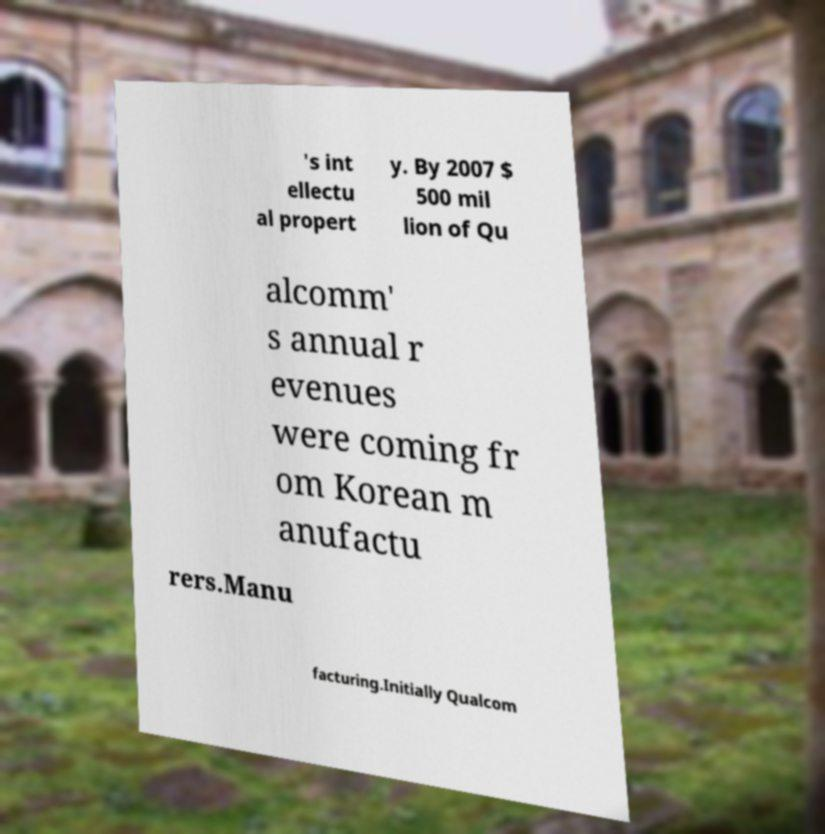There's text embedded in this image that I need extracted. Can you transcribe it verbatim? 's int ellectu al propert y. By 2007 $ 500 mil lion of Qu alcomm' s annual r evenues were coming fr om Korean m anufactu rers.Manu facturing.Initially Qualcom 